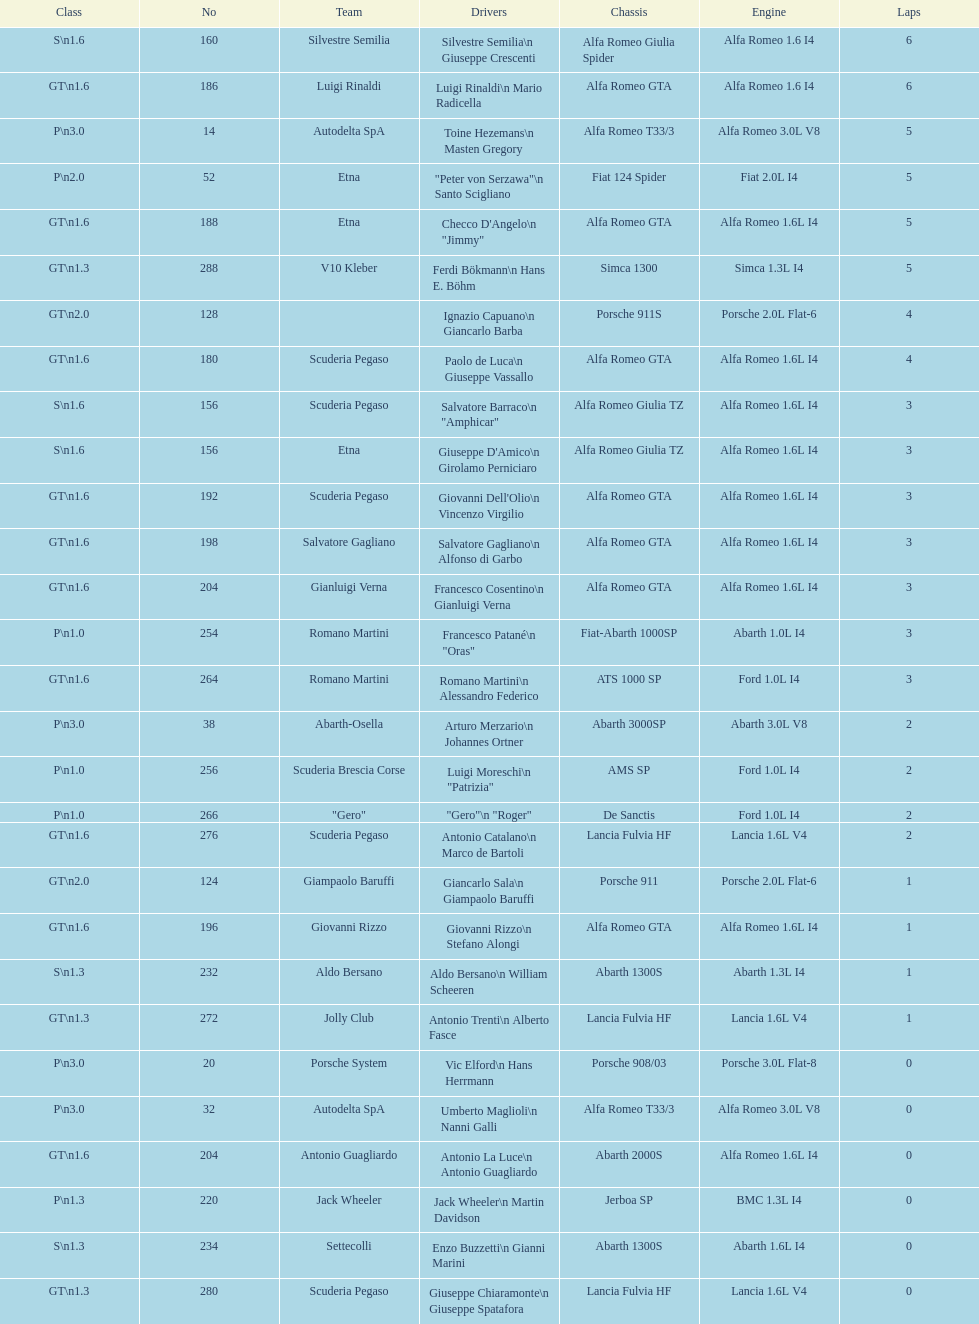How many laps does v10 kleber have? 5. 